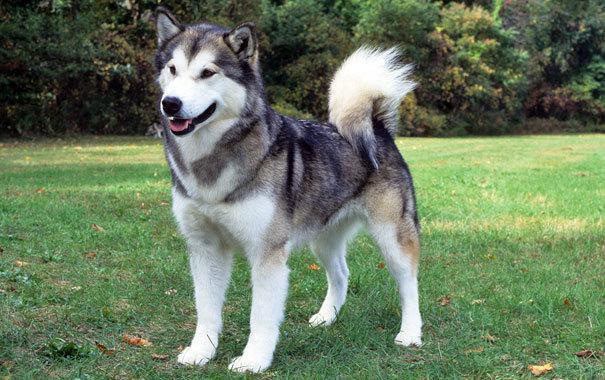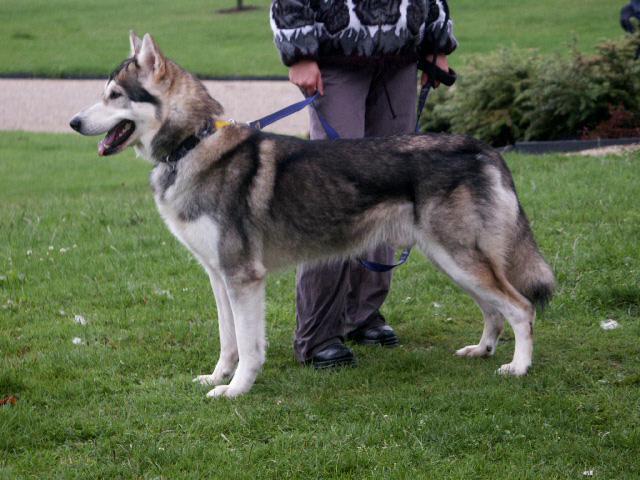The first image is the image on the left, the second image is the image on the right. Evaluate the accuracy of this statement regarding the images: "Each image shows a husky standing on all fours, and the dog on the right wears a leash.". Is it true? Answer yes or no. Yes. The first image is the image on the left, the second image is the image on the right. Examine the images to the left and right. Is the description "The right image contains one dog attached to a leash." accurate? Answer yes or no. Yes. 